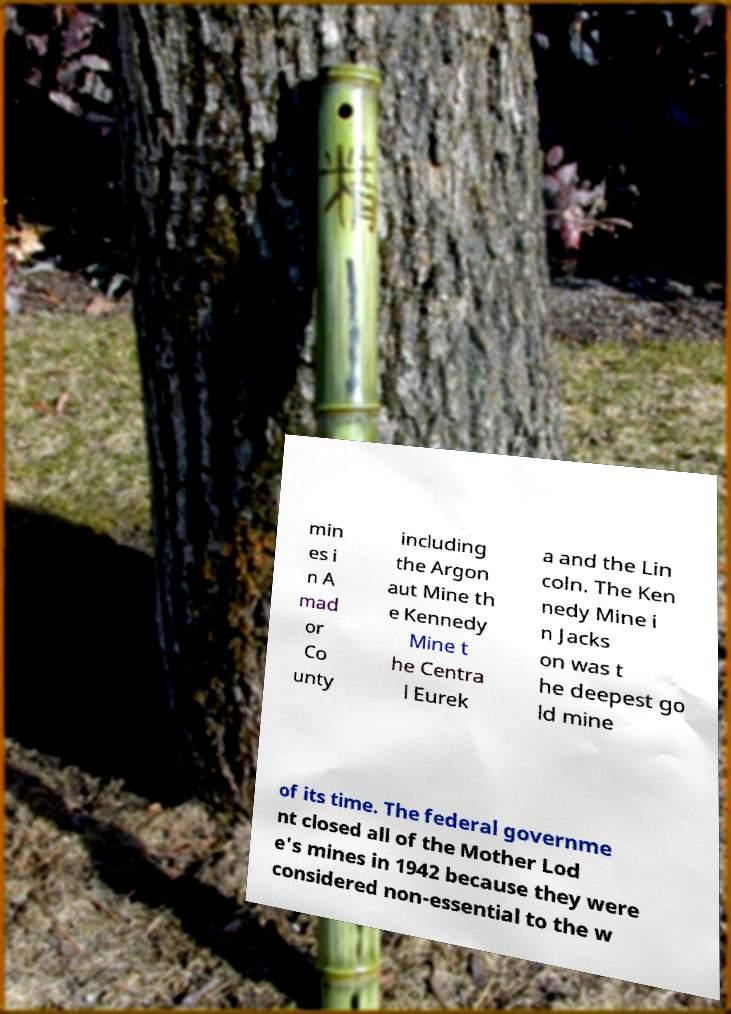For documentation purposes, I need the text within this image transcribed. Could you provide that? min es i n A mad or Co unty including the Argon aut Mine th e Kennedy Mine t he Centra l Eurek a and the Lin coln. The Ken nedy Mine i n Jacks on was t he deepest go ld mine of its time. The federal governme nt closed all of the Mother Lod e's mines in 1942 because they were considered non-essential to the w 